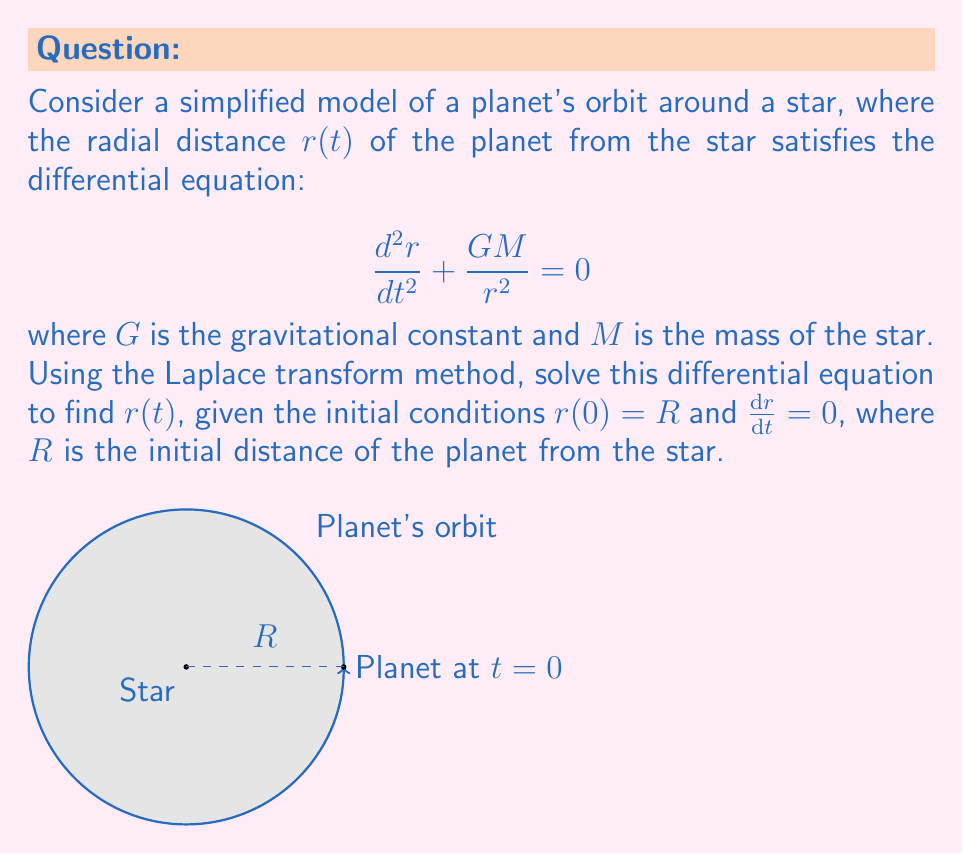Can you solve this math problem? Let's solve this step-by-step using the Laplace transform method:

1) First, let's take the Laplace transform of both sides of the equation:

   $$\mathcal{L}\left\{\frac{d^2r}{dt^2}\right\} + GM\mathcal{L}\left\{\frac{1}{r^2}\right\} = 0$$

2) Using the Laplace transform of the second derivative and the initial conditions:

   $$s^2R(s) - sr(0) - r'(0) + GM\mathcal{L}\left\{\frac{1}{r^2}\right\} = 0$$
   $$s^2R(s) - sR + GM\mathcal{L}\left\{\frac{1}{r^2}\right\} = 0$$

3) The term $\mathcal{L}\left\{\frac{1}{r^2}\right\}$ is nonlinear and makes this equation difficult to solve directly. However, for nearly circular orbits, we can approximate $r(t) \approx R$ (constant). This gives:

   $$s^2R(s) - sR + \frac{GM}{R^2} = 0$$

4) Solving for $R(s)$:

   $$R(s) = \frac{sR}{s^2 + \frac{GM}{R^3}}$$

5) This is in the form of the Laplace transform of a cosine function. The inverse Laplace transform gives:

   $$r(t) = R\cos\left(\sqrt{\frac{GM}{R^3}}t\right)$$

6) This solution represents simple harmonic motion, which is a good approximation for nearly circular orbits. The angular frequency $\omega = \sqrt{\frac{GM}{R^3}}$ is consistent with Kepler's third law of planetary motion.
Answer: $r(t) = R\cos\left(\sqrt{\frac{GM}{R^3}}t\right)$ 